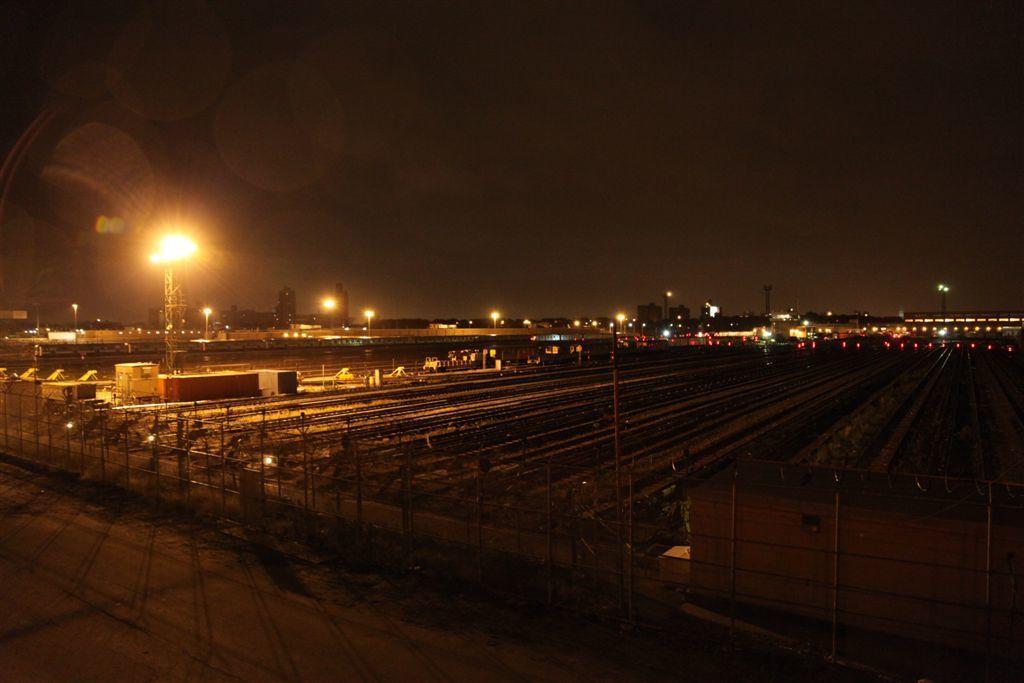Describe this image in one or two sentences. In the foreground of this image, there is a fencing and the road. In the background, there are few poles, lights, few buildings, and the dark sky. 